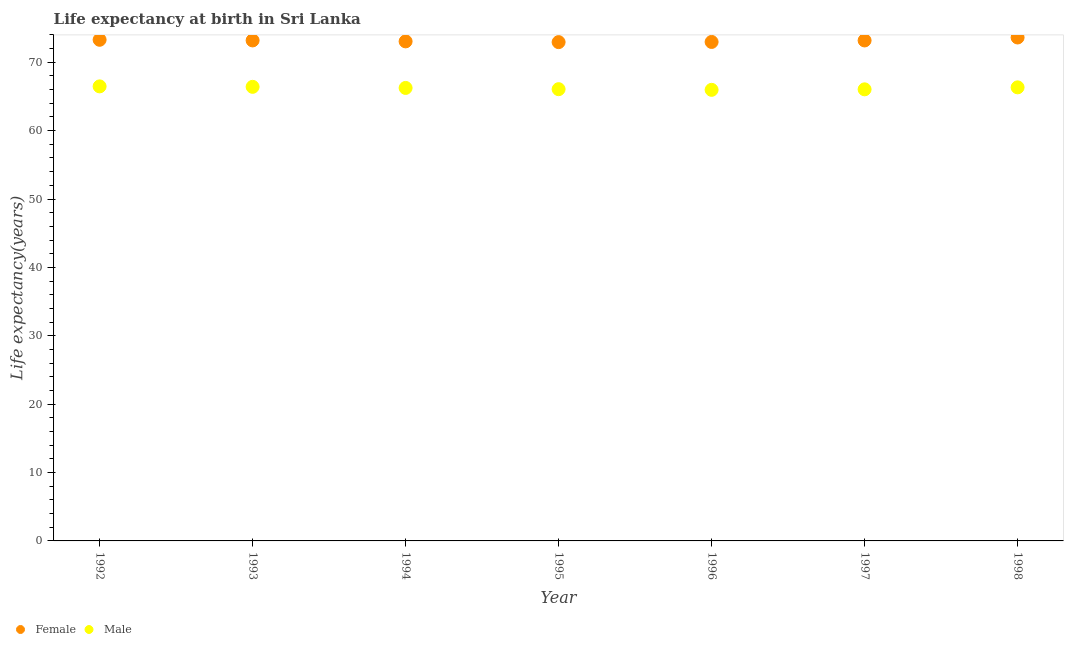What is the life expectancy(male) in 1995?
Keep it short and to the point. 66.06. Across all years, what is the maximum life expectancy(female)?
Your answer should be compact. 73.62. Across all years, what is the minimum life expectancy(male)?
Make the answer very short. 65.97. In which year was the life expectancy(female) minimum?
Make the answer very short. 1995. What is the total life expectancy(female) in the graph?
Provide a succinct answer. 512.26. What is the difference between the life expectancy(female) in 1992 and that in 1994?
Offer a terse response. 0.23. What is the difference between the life expectancy(female) in 1995 and the life expectancy(male) in 1992?
Your answer should be compact. 6.47. What is the average life expectancy(female) per year?
Ensure brevity in your answer.  73.18. In the year 1998, what is the difference between the life expectancy(female) and life expectancy(male)?
Offer a very short reply. 7.29. What is the ratio of the life expectancy(female) in 1994 to that in 1997?
Provide a short and direct response. 1. Is the difference between the life expectancy(male) in 1996 and 1998 greater than the difference between the life expectancy(female) in 1996 and 1998?
Your answer should be compact. Yes. What is the difference between the highest and the second highest life expectancy(male)?
Give a very brief answer. 0.07. What is the difference between the highest and the lowest life expectancy(female)?
Your response must be concise. 0.68. In how many years, is the life expectancy(female) greater than the average life expectancy(female) taken over all years?
Keep it short and to the point. 4. Does the life expectancy(male) monotonically increase over the years?
Offer a very short reply. No. Is the life expectancy(female) strictly greater than the life expectancy(male) over the years?
Provide a succinct answer. Yes. Is the life expectancy(female) strictly less than the life expectancy(male) over the years?
Give a very brief answer. No. How many years are there in the graph?
Provide a short and direct response. 7. What is the difference between two consecutive major ticks on the Y-axis?
Ensure brevity in your answer.  10. Does the graph contain any zero values?
Provide a succinct answer. No. Does the graph contain grids?
Make the answer very short. No. Where does the legend appear in the graph?
Your answer should be compact. Bottom left. How many legend labels are there?
Provide a succinct answer. 2. How are the legend labels stacked?
Offer a very short reply. Horizontal. What is the title of the graph?
Provide a succinct answer. Life expectancy at birth in Sri Lanka. Does "By country of origin" appear as one of the legend labels in the graph?
Ensure brevity in your answer.  No. What is the label or title of the X-axis?
Provide a short and direct response. Year. What is the label or title of the Y-axis?
Keep it short and to the point. Life expectancy(years). What is the Life expectancy(years) of Female in 1992?
Your answer should be compact. 73.29. What is the Life expectancy(years) in Male in 1992?
Ensure brevity in your answer.  66.47. What is the Life expectancy(years) of Female in 1993?
Make the answer very short. 73.19. What is the Life expectancy(years) in Male in 1993?
Provide a short and direct response. 66.41. What is the Life expectancy(years) of Female in 1994?
Keep it short and to the point. 73.05. What is the Life expectancy(years) of Male in 1994?
Provide a short and direct response. 66.25. What is the Life expectancy(years) in Female in 1995?
Keep it short and to the point. 72.94. What is the Life expectancy(years) in Male in 1995?
Make the answer very short. 66.06. What is the Life expectancy(years) in Female in 1996?
Your answer should be very brief. 72.97. What is the Life expectancy(years) of Male in 1996?
Make the answer very short. 65.97. What is the Life expectancy(years) in Female in 1997?
Offer a very short reply. 73.19. What is the Life expectancy(years) of Male in 1997?
Keep it short and to the point. 66.04. What is the Life expectancy(years) of Female in 1998?
Keep it short and to the point. 73.62. What is the Life expectancy(years) in Male in 1998?
Give a very brief answer. 66.33. Across all years, what is the maximum Life expectancy(years) in Female?
Offer a very short reply. 73.62. Across all years, what is the maximum Life expectancy(years) of Male?
Make the answer very short. 66.47. Across all years, what is the minimum Life expectancy(years) in Female?
Give a very brief answer. 72.94. Across all years, what is the minimum Life expectancy(years) of Male?
Your answer should be compact. 65.97. What is the total Life expectancy(years) in Female in the graph?
Provide a succinct answer. 512.26. What is the total Life expectancy(years) of Male in the graph?
Ensure brevity in your answer.  463.52. What is the difference between the Life expectancy(years) in Female in 1992 and that in 1993?
Your answer should be very brief. 0.09. What is the difference between the Life expectancy(years) in Male in 1992 and that in 1993?
Keep it short and to the point. 0.07. What is the difference between the Life expectancy(years) in Female in 1992 and that in 1994?
Offer a very short reply. 0.23. What is the difference between the Life expectancy(years) in Male in 1992 and that in 1994?
Provide a succinct answer. 0.23. What is the difference between the Life expectancy(years) of Female in 1992 and that in 1995?
Provide a short and direct response. 0.34. What is the difference between the Life expectancy(years) in Male in 1992 and that in 1995?
Provide a succinct answer. 0.41. What is the difference between the Life expectancy(years) in Female in 1992 and that in 1996?
Offer a terse response. 0.32. What is the difference between the Life expectancy(years) of Male in 1992 and that in 1996?
Make the answer very short. 0.51. What is the difference between the Life expectancy(years) in Female in 1992 and that in 1997?
Give a very brief answer. 0.1. What is the difference between the Life expectancy(years) in Male in 1992 and that in 1997?
Provide a short and direct response. 0.43. What is the difference between the Life expectancy(years) in Female in 1992 and that in 1998?
Your answer should be compact. -0.34. What is the difference between the Life expectancy(years) of Male in 1992 and that in 1998?
Your answer should be very brief. 0.14. What is the difference between the Life expectancy(years) in Female in 1993 and that in 1994?
Ensure brevity in your answer.  0.14. What is the difference between the Life expectancy(years) of Male in 1993 and that in 1994?
Provide a short and direct response. 0.16. What is the difference between the Life expectancy(years) of Female in 1993 and that in 1995?
Make the answer very short. 0.25. What is the difference between the Life expectancy(years) in Male in 1993 and that in 1995?
Make the answer very short. 0.34. What is the difference between the Life expectancy(years) in Female in 1993 and that in 1996?
Give a very brief answer. 0.22. What is the difference between the Life expectancy(years) in Male in 1993 and that in 1996?
Ensure brevity in your answer.  0.44. What is the difference between the Life expectancy(years) in Female in 1993 and that in 1997?
Offer a very short reply. 0. What is the difference between the Life expectancy(years) of Male in 1993 and that in 1997?
Offer a very short reply. 0.37. What is the difference between the Life expectancy(years) of Female in 1993 and that in 1998?
Your answer should be very brief. -0.43. What is the difference between the Life expectancy(years) in Male in 1993 and that in 1998?
Offer a very short reply. 0.07. What is the difference between the Life expectancy(years) of Female in 1994 and that in 1995?
Provide a succinct answer. 0.11. What is the difference between the Life expectancy(years) in Male in 1994 and that in 1995?
Provide a short and direct response. 0.18. What is the difference between the Life expectancy(years) of Female in 1994 and that in 1996?
Make the answer very short. 0.08. What is the difference between the Life expectancy(years) of Male in 1994 and that in 1996?
Ensure brevity in your answer.  0.28. What is the difference between the Life expectancy(years) of Female in 1994 and that in 1997?
Your answer should be compact. -0.14. What is the difference between the Life expectancy(years) in Male in 1994 and that in 1997?
Provide a short and direct response. 0.2. What is the difference between the Life expectancy(years) in Female in 1994 and that in 1998?
Give a very brief answer. -0.57. What is the difference between the Life expectancy(years) of Male in 1994 and that in 1998?
Your answer should be compact. -0.09. What is the difference between the Life expectancy(years) in Female in 1995 and that in 1996?
Make the answer very short. -0.03. What is the difference between the Life expectancy(years) of Male in 1995 and that in 1996?
Offer a very short reply. 0.1. What is the difference between the Life expectancy(years) of Female in 1995 and that in 1997?
Offer a terse response. -0.24. What is the difference between the Life expectancy(years) in Male in 1995 and that in 1997?
Offer a terse response. 0.02. What is the difference between the Life expectancy(years) of Female in 1995 and that in 1998?
Provide a short and direct response. -0.68. What is the difference between the Life expectancy(years) in Male in 1995 and that in 1998?
Make the answer very short. -0.27. What is the difference between the Life expectancy(years) of Female in 1996 and that in 1997?
Your answer should be very brief. -0.22. What is the difference between the Life expectancy(years) of Male in 1996 and that in 1997?
Your answer should be compact. -0.07. What is the difference between the Life expectancy(years) in Female in 1996 and that in 1998?
Keep it short and to the point. -0.65. What is the difference between the Life expectancy(years) in Male in 1996 and that in 1998?
Ensure brevity in your answer.  -0.36. What is the difference between the Life expectancy(years) of Female in 1997 and that in 1998?
Offer a very short reply. -0.43. What is the difference between the Life expectancy(years) of Male in 1997 and that in 1998?
Offer a very short reply. -0.29. What is the difference between the Life expectancy(years) in Female in 1992 and the Life expectancy(years) in Male in 1993?
Offer a very short reply. 6.88. What is the difference between the Life expectancy(years) of Female in 1992 and the Life expectancy(years) of Male in 1994?
Keep it short and to the point. 7.04. What is the difference between the Life expectancy(years) in Female in 1992 and the Life expectancy(years) in Male in 1995?
Provide a succinct answer. 7.22. What is the difference between the Life expectancy(years) of Female in 1992 and the Life expectancy(years) of Male in 1996?
Provide a succinct answer. 7.32. What is the difference between the Life expectancy(years) in Female in 1992 and the Life expectancy(years) in Male in 1997?
Provide a short and direct response. 7.25. What is the difference between the Life expectancy(years) in Female in 1992 and the Life expectancy(years) in Male in 1998?
Offer a terse response. 6.96. What is the difference between the Life expectancy(years) in Female in 1993 and the Life expectancy(years) in Male in 1994?
Your response must be concise. 6.95. What is the difference between the Life expectancy(years) of Female in 1993 and the Life expectancy(years) of Male in 1995?
Keep it short and to the point. 7.13. What is the difference between the Life expectancy(years) of Female in 1993 and the Life expectancy(years) of Male in 1996?
Your answer should be compact. 7.23. What is the difference between the Life expectancy(years) of Female in 1993 and the Life expectancy(years) of Male in 1997?
Your answer should be compact. 7.15. What is the difference between the Life expectancy(years) of Female in 1993 and the Life expectancy(years) of Male in 1998?
Your answer should be compact. 6.86. What is the difference between the Life expectancy(years) of Female in 1994 and the Life expectancy(years) of Male in 1995?
Keep it short and to the point. 6.99. What is the difference between the Life expectancy(years) in Female in 1994 and the Life expectancy(years) in Male in 1996?
Your answer should be compact. 7.09. What is the difference between the Life expectancy(years) in Female in 1994 and the Life expectancy(years) in Male in 1997?
Keep it short and to the point. 7.01. What is the difference between the Life expectancy(years) of Female in 1994 and the Life expectancy(years) of Male in 1998?
Offer a very short reply. 6.72. What is the difference between the Life expectancy(years) of Female in 1995 and the Life expectancy(years) of Male in 1996?
Provide a succinct answer. 6.98. What is the difference between the Life expectancy(years) of Female in 1995 and the Life expectancy(years) of Male in 1997?
Make the answer very short. 6.91. What is the difference between the Life expectancy(years) of Female in 1995 and the Life expectancy(years) of Male in 1998?
Your answer should be compact. 6.61. What is the difference between the Life expectancy(years) of Female in 1996 and the Life expectancy(years) of Male in 1997?
Keep it short and to the point. 6.93. What is the difference between the Life expectancy(years) of Female in 1996 and the Life expectancy(years) of Male in 1998?
Offer a very short reply. 6.64. What is the difference between the Life expectancy(years) of Female in 1997 and the Life expectancy(years) of Male in 1998?
Your response must be concise. 6.86. What is the average Life expectancy(years) in Female per year?
Offer a terse response. 73.18. What is the average Life expectancy(years) of Male per year?
Offer a very short reply. 66.22. In the year 1992, what is the difference between the Life expectancy(years) in Female and Life expectancy(years) in Male?
Your answer should be compact. 6.81. In the year 1993, what is the difference between the Life expectancy(years) in Female and Life expectancy(years) in Male?
Offer a terse response. 6.79. In the year 1994, what is the difference between the Life expectancy(years) of Female and Life expectancy(years) of Male?
Ensure brevity in your answer.  6.81. In the year 1995, what is the difference between the Life expectancy(years) in Female and Life expectancy(years) in Male?
Provide a short and direct response. 6.88. In the year 1996, what is the difference between the Life expectancy(years) in Female and Life expectancy(years) in Male?
Keep it short and to the point. 7. In the year 1997, what is the difference between the Life expectancy(years) of Female and Life expectancy(years) of Male?
Your answer should be compact. 7.15. In the year 1998, what is the difference between the Life expectancy(years) in Female and Life expectancy(years) in Male?
Provide a succinct answer. 7.29. What is the ratio of the Life expectancy(years) of Female in 1992 to that in 1993?
Keep it short and to the point. 1. What is the ratio of the Life expectancy(years) in Male in 1992 to that in 1993?
Your response must be concise. 1. What is the ratio of the Life expectancy(years) in Male in 1992 to that in 1995?
Offer a very short reply. 1.01. What is the ratio of the Life expectancy(years) in Female in 1992 to that in 1996?
Offer a terse response. 1. What is the ratio of the Life expectancy(years) in Male in 1992 to that in 1996?
Give a very brief answer. 1.01. What is the ratio of the Life expectancy(years) of Male in 1992 to that in 1997?
Ensure brevity in your answer.  1.01. What is the ratio of the Life expectancy(years) in Male in 1992 to that in 1998?
Offer a terse response. 1. What is the ratio of the Life expectancy(years) of Male in 1993 to that in 1994?
Make the answer very short. 1. What is the ratio of the Life expectancy(years) of Female in 1993 to that in 1995?
Your answer should be very brief. 1. What is the ratio of the Life expectancy(years) in Male in 1993 to that in 1995?
Make the answer very short. 1.01. What is the ratio of the Life expectancy(years) in Female in 1993 to that in 1996?
Ensure brevity in your answer.  1. What is the ratio of the Life expectancy(years) of Male in 1993 to that in 1996?
Make the answer very short. 1.01. What is the ratio of the Life expectancy(years) in Male in 1993 to that in 1998?
Make the answer very short. 1. What is the ratio of the Life expectancy(years) in Female in 1994 to that in 1996?
Keep it short and to the point. 1. What is the ratio of the Life expectancy(years) of Male in 1994 to that in 1996?
Ensure brevity in your answer.  1. What is the ratio of the Life expectancy(years) of Male in 1994 to that in 1997?
Offer a terse response. 1. What is the ratio of the Life expectancy(years) in Male in 1994 to that in 1998?
Provide a short and direct response. 1. What is the ratio of the Life expectancy(years) in Female in 1995 to that in 1996?
Your answer should be compact. 1. What is the ratio of the Life expectancy(years) in Male in 1995 to that in 1996?
Your answer should be compact. 1. What is the ratio of the Life expectancy(years) of Male in 1995 to that in 1997?
Provide a short and direct response. 1. What is the ratio of the Life expectancy(years) in Female in 1995 to that in 1998?
Your answer should be compact. 0.99. What is the ratio of the Life expectancy(years) of Male in 1995 to that in 1998?
Make the answer very short. 1. What is the ratio of the Life expectancy(years) in Female in 1996 to that in 1997?
Provide a short and direct response. 1. What is the ratio of the Life expectancy(years) in Male in 1996 to that in 1998?
Give a very brief answer. 0.99. What is the ratio of the Life expectancy(years) in Male in 1997 to that in 1998?
Keep it short and to the point. 1. What is the difference between the highest and the second highest Life expectancy(years) in Female?
Offer a terse response. 0.34. What is the difference between the highest and the second highest Life expectancy(years) of Male?
Keep it short and to the point. 0.07. What is the difference between the highest and the lowest Life expectancy(years) of Female?
Your answer should be compact. 0.68. What is the difference between the highest and the lowest Life expectancy(years) in Male?
Provide a succinct answer. 0.51. 